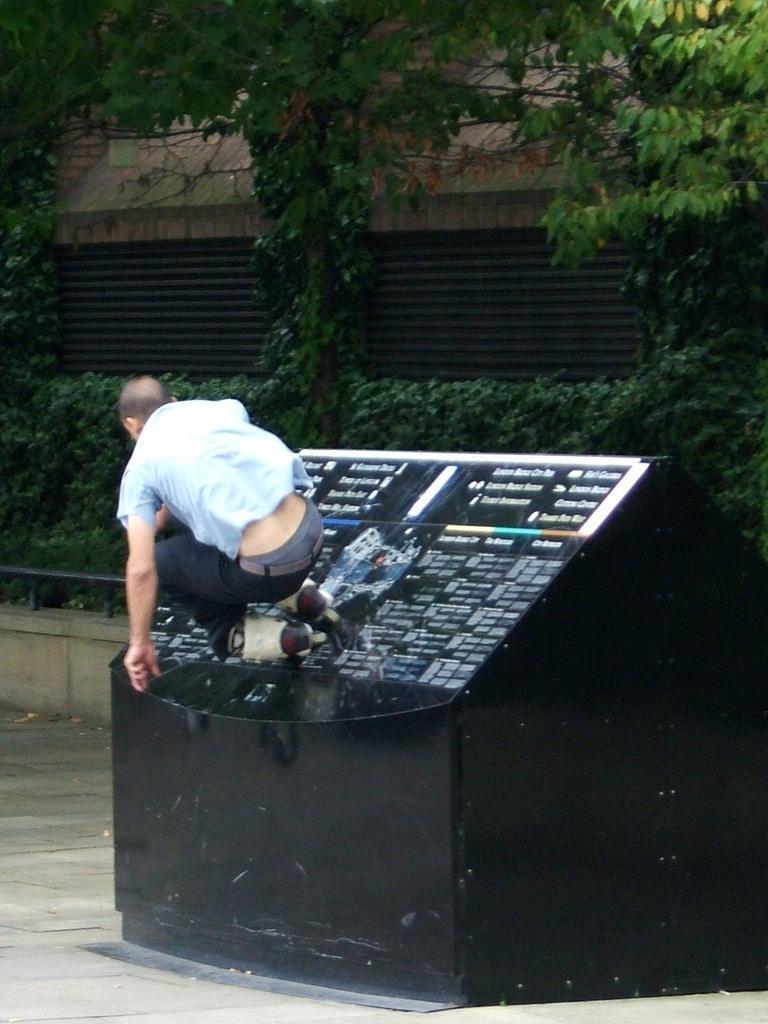How would you summarize this image in a sentence or two? In this picture there is a man who is wearing a skating shoes, was jumping over the table which is on the side of the road. The table is in black colour and the man is wearing a blue shirt and a black pant. Behind the table there is plants and there is roof of some building. 